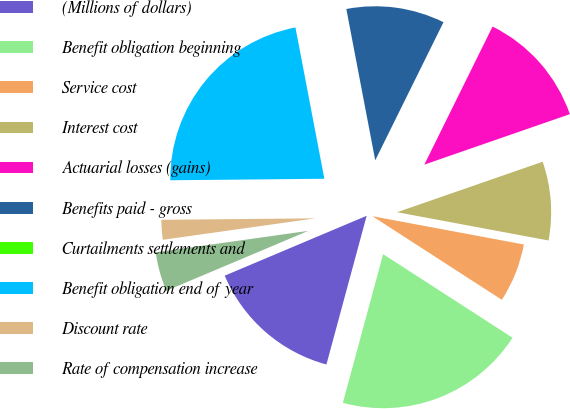<chart> <loc_0><loc_0><loc_500><loc_500><pie_chart><fcel>(Millions of dollars)<fcel>Benefit obligation beginning<fcel>Service cost<fcel>Interest cost<fcel>Actuarial losses (gains)<fcel>Benefits paid - gross<fcel>Curtailments settlements and<fcel>Benefit obligation end of year<fcel>Discount rate<fcel>Rate of compensation increase<nl><fcel>14.44%<fcel>20.08%<fcel>6.19%<fcel>8.25%<fcel>12.38%<fcel>10.31%<fcel>0.0%<fcel>22.15%<fcel>2.07%<fcel>4.13%<nl></chart> 